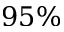Convert formula to latex. <formula><loc_0><loc_0><loc_500><loc_500>9 5 \%</formula> 